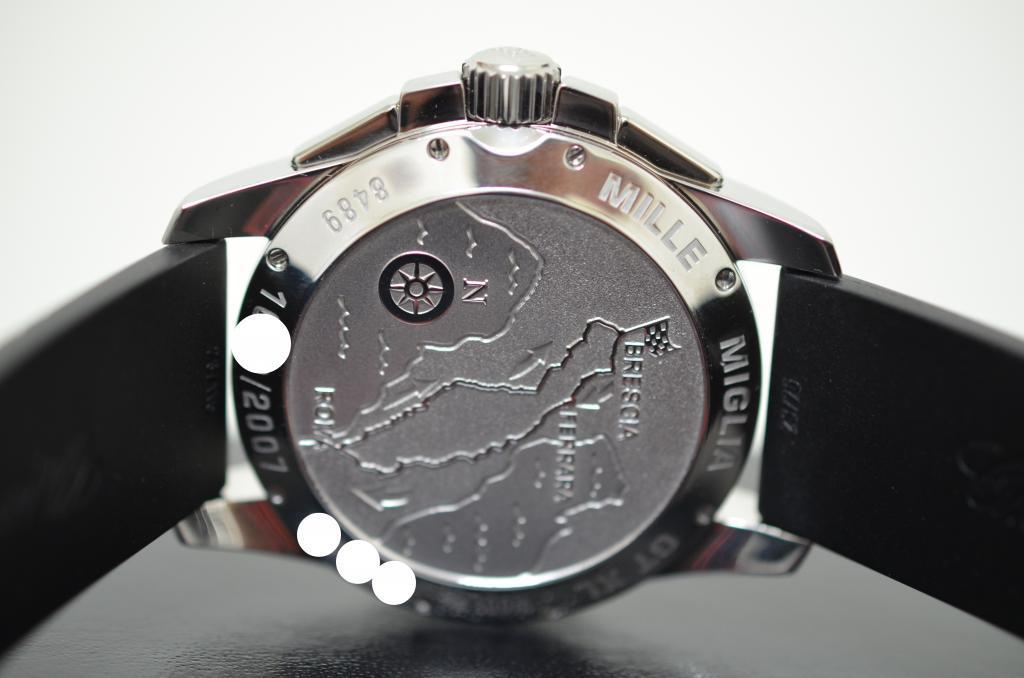<image>
Offer a succinct explanation of the picture presented. A watch with the words Mille Miglia on the outer edge. 